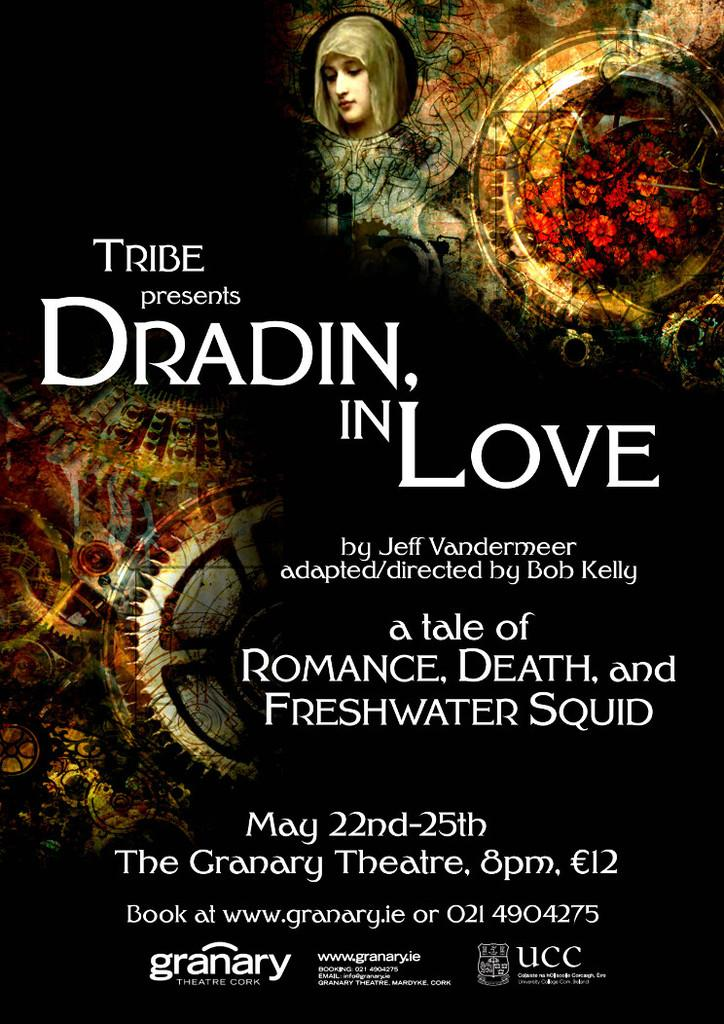<image>
Create a compact narrative representing the image presented. An advertisement for the play Dradin, In Love includes details on the location and dates. 